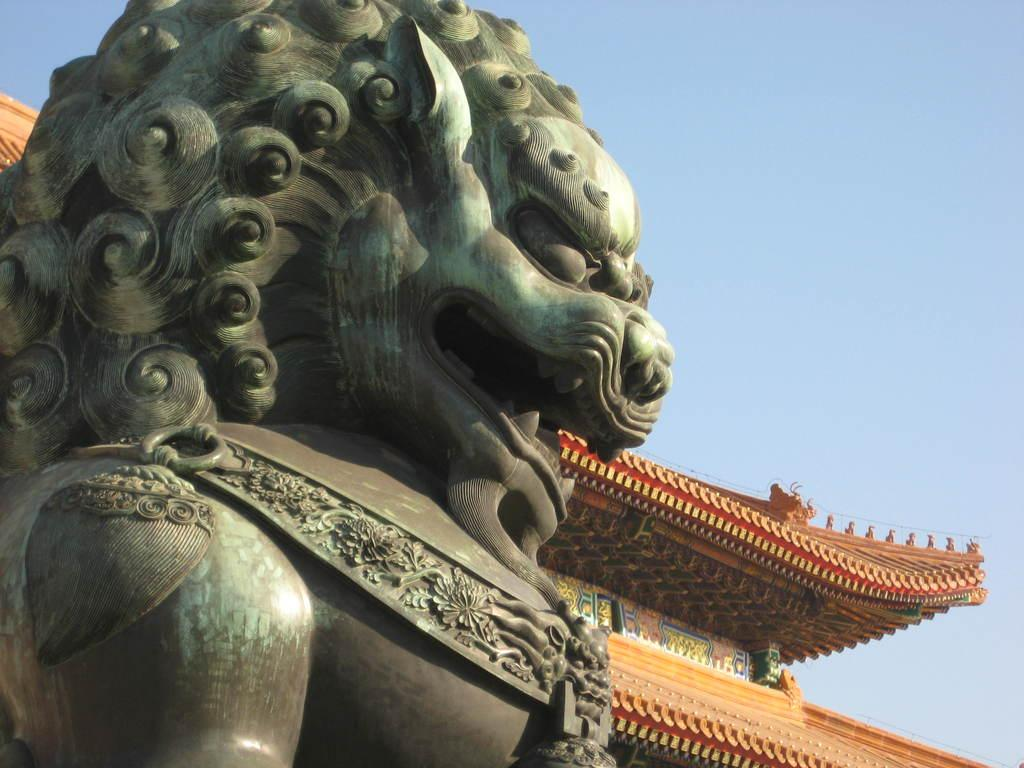What is the main subject in the image? There is a statue in the image. Can you describe the color of the statue? The statue is in green and grey color. What can be seen in the background of the image? There is a building in the background of the image. Can you describe the color of the building? The building is in red and brown color. What is visible in the sky in the image? The sky is visible in the background of the image. What type of music is being played by the fan in the image? There is no fan or music present in the image; it features a statue and a building in the background. 